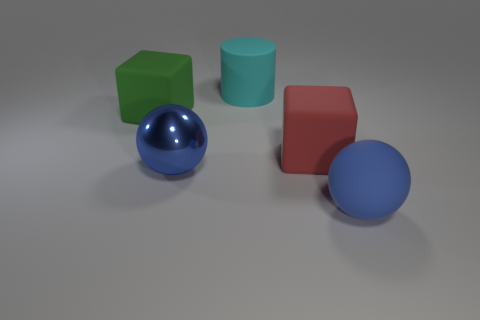Do the large rubber ball and the big metallic sphere have the same color?
Keep it short and to the point. Yes. There is a object that is the same color as the shiny ball; what shape is it?
Give a very brief answer. Sphere. Is the number of red matte things on the left side of the large blue rubber sphere greater than the number of small brown spheres?
Your answer should be compact. Yes. How many big things are either shiny things or cyan rubber spheres?
Ensure brevity in your answer.  1. How many cyan objects have the same shape as the big red rubber object?
Your answer should be very brief. 0. What is the blue ball behind the ball right of the red thing made of?
Provide a short and direct response. Metal. What number of blue objects are big shiny things or small cylinders?
Provide a short and direct response. 1. There is another big thing that is the same shape as the large red thing; what material is it?
Keep it short and to the point. Rubber. Are there the same number of large green things behind the cyan object and big green rubber blocks?
Make the answer very short. No. There is a thing that is both right of the large cyan thing and behind the blue shiny thing; how big is it?
Provide a short and direct response. Large. 